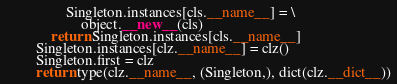Convert code to text. <code><loc_0><loc_0><loc_500><loc_500><_Python_>                Singleton.instances[cls.__name__] = \
                    object.__new__(cls)
            return Singleton.instances[cls.__name__]
        Singleton.instances[clz.__name__] = clz()
        Singleton.first = clz
        return type(clz.__name__, (Singleton,), dict(clz.__dict__))</code> 